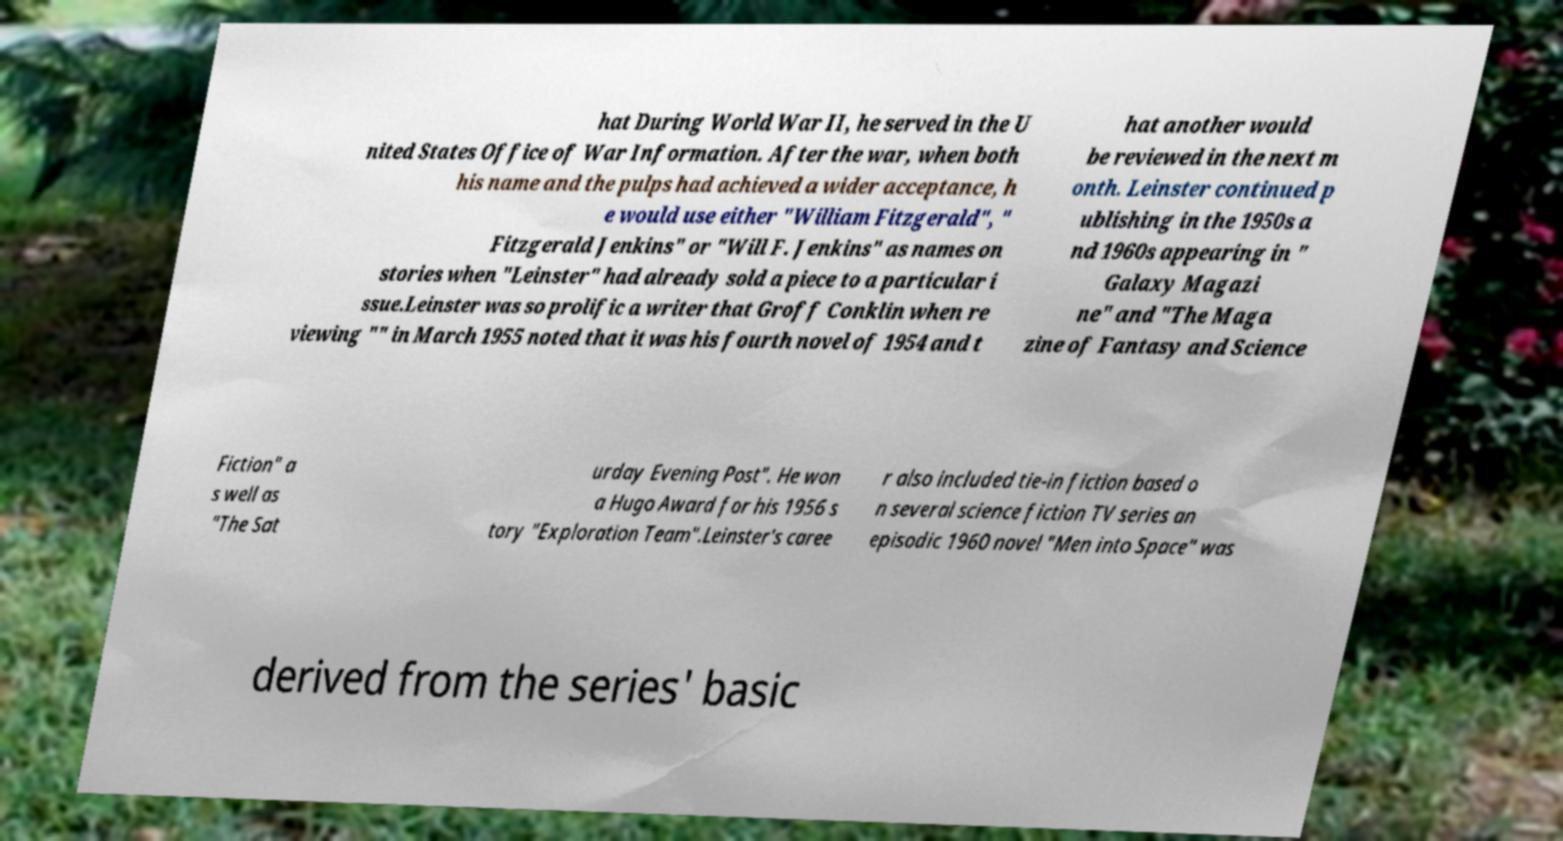Could you extract and type out the text from this image? hat During World War II, he served in the U nited States Office of War Information. After the war, when both his name and the pulps had achieved a wider acceptance, h e would use either "William Fitzgerald", " Fitzgerald Jenkins" or "Will F. Jenkins" as names on stories when "Leinster" had already sold a piece to a particular i ssue.Leinster was so prolific a writer that Groff Conklin when re viewing "" in March 1955 noted that it was his fourth novel of 1954 and t hat another would be reviewed in the next m onth. Leinster continued p ublishing in the 1950s a nd 1960s appearing in " Galaxy Magazi ne" and "The Maga zine of Fantasy and Science Fiction" a s well as "The Sat urday Evening Post". He won a Hugo Award for his 1956 s tory "Exploration Team".Leinster's caree r also included tie-in fiction based o n several science fiction TV series an episodic 1960 novel "Men into Space" was derived from the series' basic 